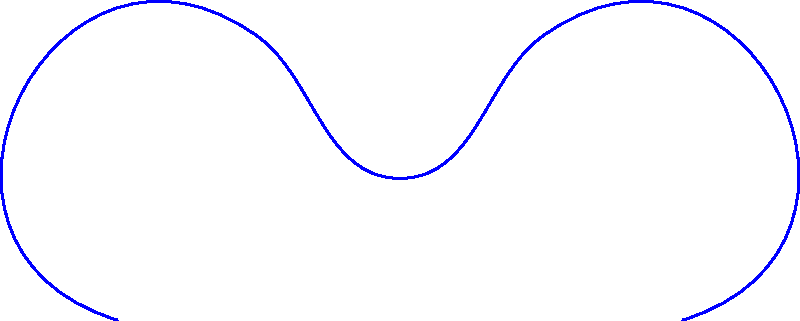In a children's science museum, there's an interactive exhibit featuring a curved mirror shaped like a Stegosaurus fossil. A light ray from point A hits the mirror at point I and reflects. If the angle between the incident ray and the normal to the surface at I is 30°, what is the angle between the reflected ray and the normal? Let's approach this step-by-step:

1. Recall the law of reflection: The angle of incidence equals the angle of reflection.

2. In this case, we're given that the angle between the incident ray and the normal is 30°.

3. The normal line is always perpendicular to the tangent line at the point of incidence on the curved surface.

4. The reflected ray will make the same angle with the normal as the incident ray, but on the opposite side.

5. Therefore, the angle between the reflected ray and the normal will also be 30°.

This principle holds true regardless of the shape of the mirror, be it flat or curved like our dinosaur fossil. It's a fundamental concept in optics that children learning about light and reflection would find fascinating, especially when presented in the context of a dinosaur exhibit!
Answer: 30° 